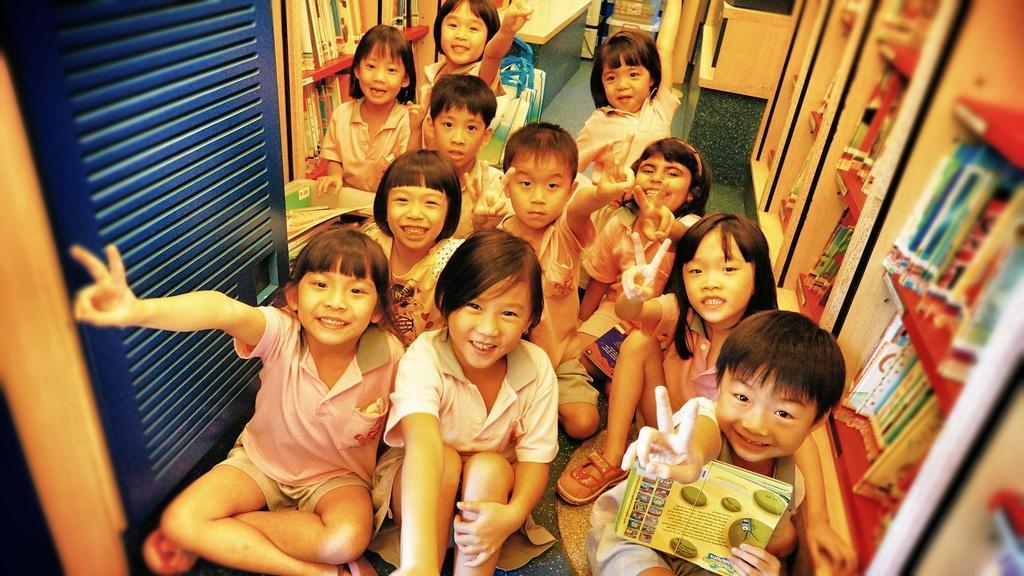Can you describe this image briefly? In this image there are group of children sitting on the floor, there are children truncated towards the bottom of the image, there is a child holding an object, there is a shelf truncated towards the right of the image, there are objects in the shelf, there is a shelve truncated towards the top of the image, there is a table truncated towards the top of the image, there are books truncated towards the top of the image, there is an object truncated towards the top of the image, there is door truncated towards the top of the image, there is an object truncated towards the left of the image. 